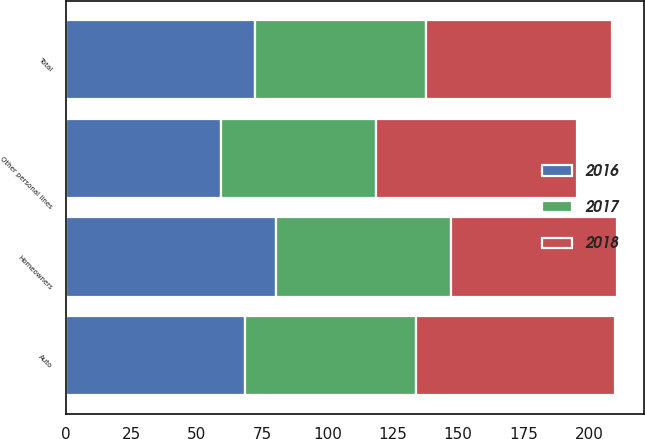Convert chart. <chart><loc_0><loc_0><loc_500><loc_500><stacked_bar_chart><ecel><fcel>Auto<fcel>Homeowners<fcel>Other personal lines<fcel>Total<nl><fcel>2017<fcel>65.2<fcel>66.9<fcel>59.5<fcel>65.4<nl><fcel>2016<fcel>68.6<fcel>80.3<fcel>59.1<fcel>72.4<nl><fcel>2018<fcel>76.1<fcel>63.5<fcel>77<fcel>71.1<nl></chart> 